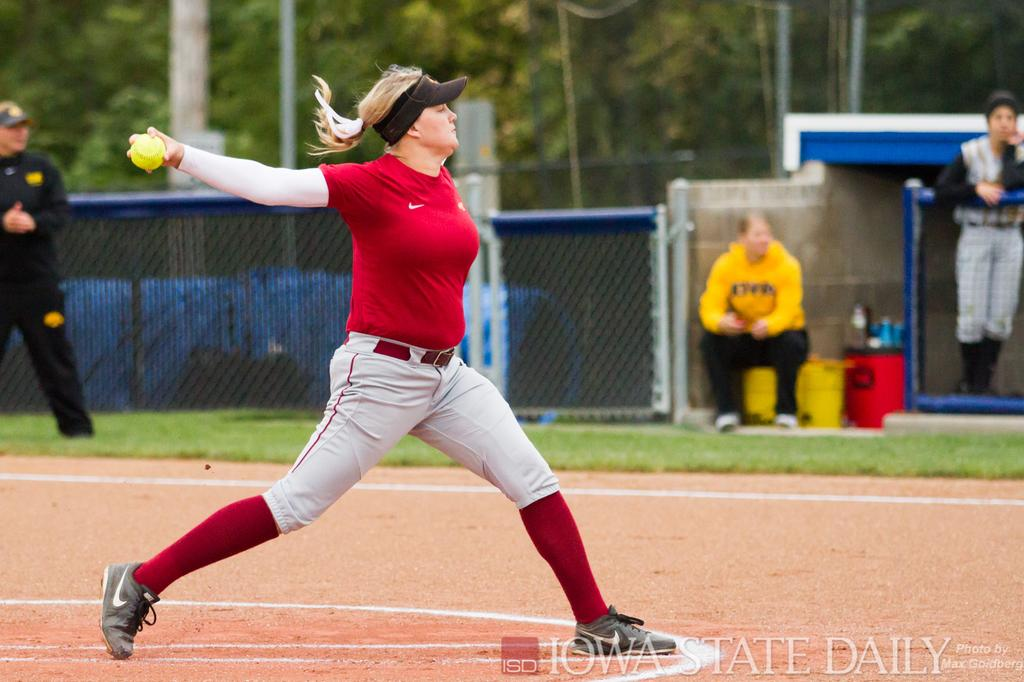<image>
Present a compact description of the photo's key features. A softball player pitches the ball for the Iowa State team. 